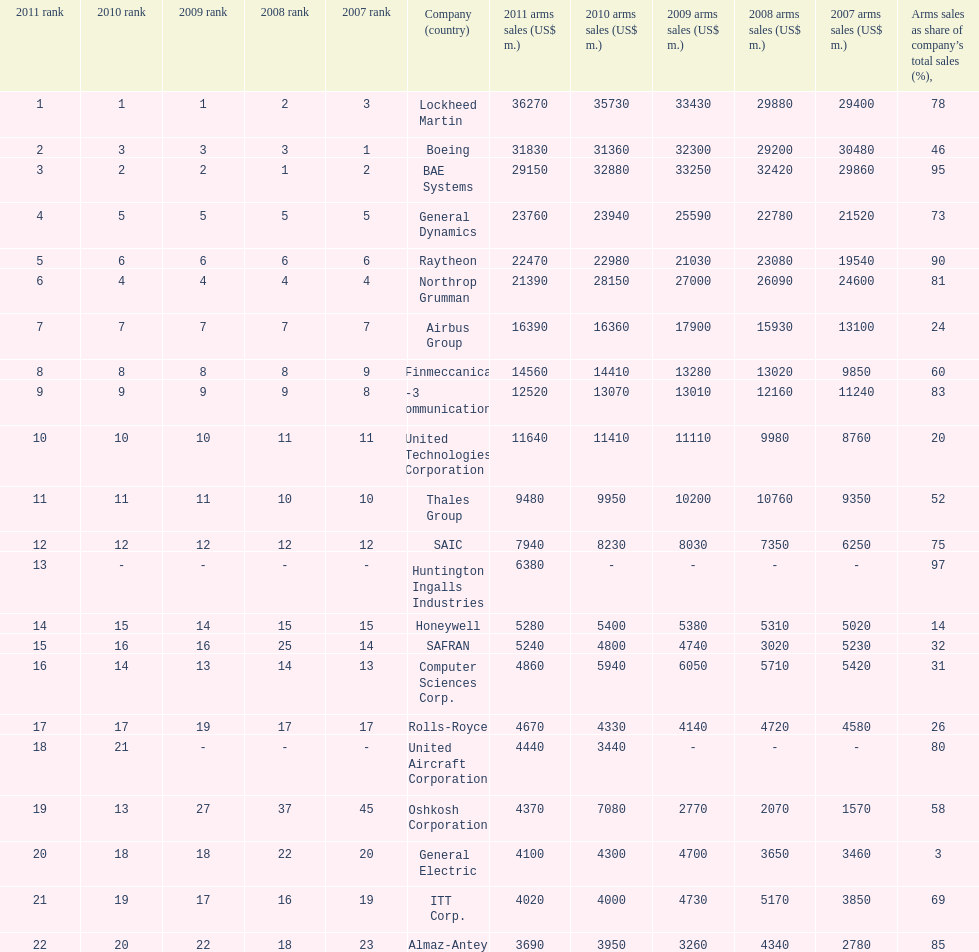Which is the only company to have under 10% arms sales as share of company's total sales? General Electric. 